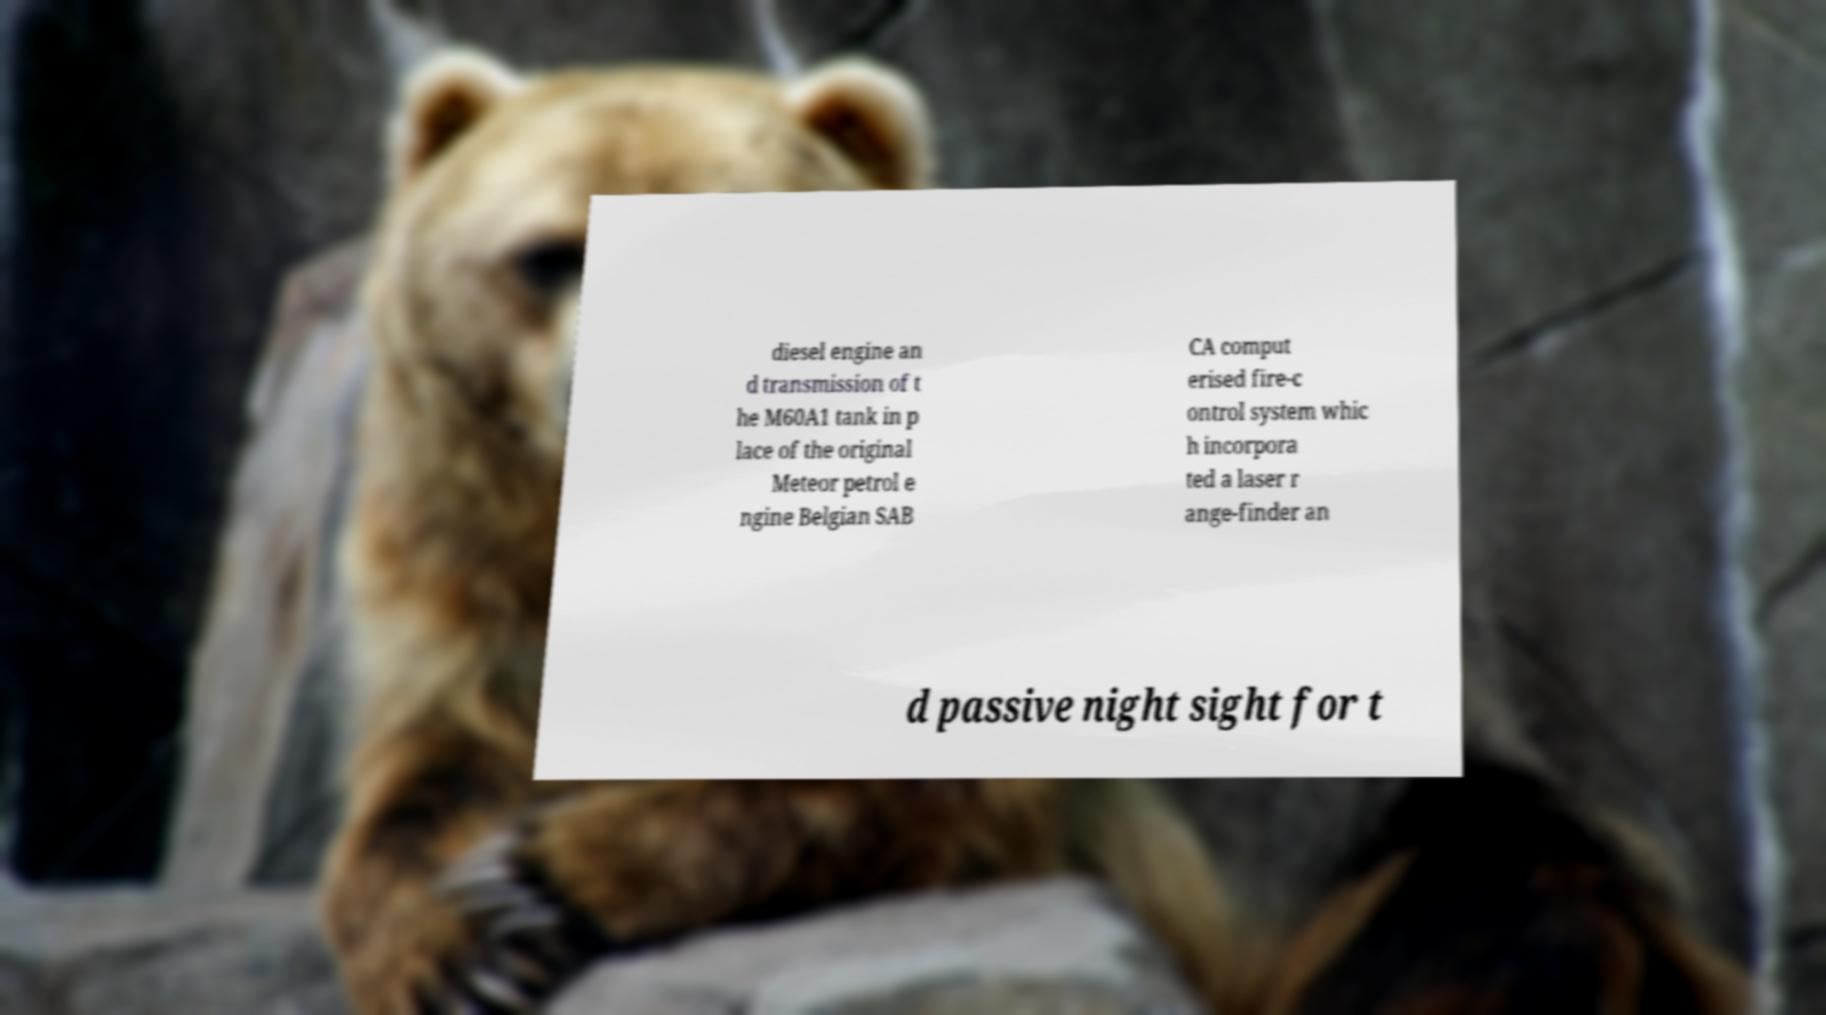What messages or text are displayed in this image? I need them in a readable, typed format. diesel engine an d transmission of t he M60A1 tank in p lace of the original Meteor petrol e ngine Belgian SAB CA comput erised fire-c ontrol system whic h incorpora ted a laser r ange-finder an d passive night sight for t 